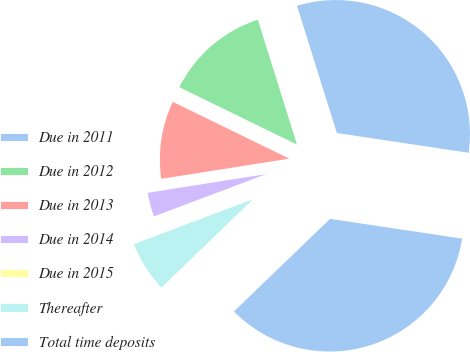<chart> <loc_0><loc_0><loc_500><loc_500><pie_chart><fcel>Due in 2011<fcel>Due in 2012<fcel>Due in 2013<fcel>Due in 2014<fcel>Due in 2015<fcel>Thereafter<fcel>Total time deposits<nl><fcel>32.2%<fcel>12.95%<fcel>9.71%<fcel>3.24%<fcel>0.0%<fcel>6.47%<fcel>35.43%<nl></chart> 